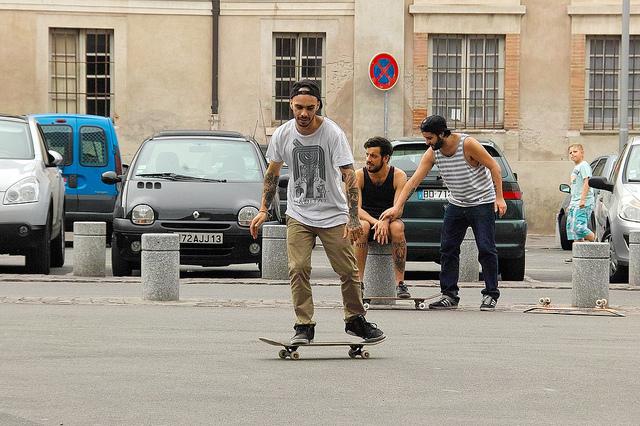What is the man sitting on?
Quick response, please. Skateboard. Is the man traveling?
Concise answer only. Yes. How many people in the picture?
Keep it brief. 4. How many of these people are riding skateboards?
Give a very brief answer. 1. What color are their shirts?
Concise answer only. White and black. 